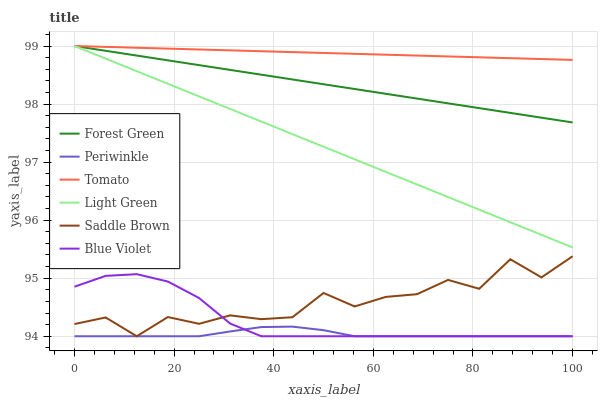Does Forest Green have the minimum area under the curve?
Answer yes or no. No. Does Forest Green have the maximum area under the curve?
Answer yes or no. No. Is Forest Green the smoothest?
Answer yes or no. No. Is Forest Green the roughest?
Answer yes or no. No. Does Forest Green have the lowest value?
Answer yes or no. No. Does Periwinkle have the highest value?
Answer yes or no. No. Is Periwinkle less than Light Green?
Answer yes or no. Yes. Is Forest Green greater than Saddle Brown?
Answer yes or no. Yes. Does Periwinkle intersect Light Green?
Answer yes or no. No. 